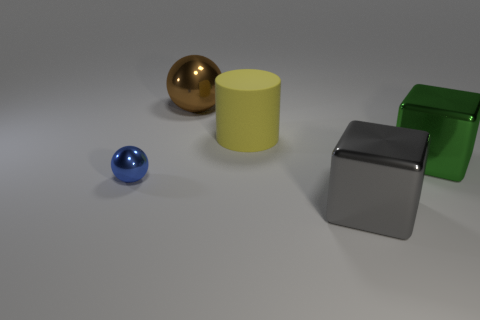How many objects are on the left side of the big gray metal object and in front of the brown metallic thing?
Provide a short and direct response. 2. Is there anything else that is the same material as the yellow thing?
Offer a terse response. No. Are there the same number of large brown things that are right of the cylinder and blue balls behind the tiny blue ball?
Give a very brief answer. Yes. Does the brown sphere have the same material as the green cube?
Make the answer very short. Yes. How many blue things are either matte cylinders or big things?
Keep it short and to the point. 0. What number of tiny blue objects are the same shape as the big brown object?
Offer a very short reply. 1. What is the big brown object made of?
Keep it short and to the point. Metal. Is the number of large green things in front of the large green block the same as the number of tiny cyan rubber blocks?
Provide a short and direct response. Yes. What shape is the yellow rubber object that is the same size as the gray metal thing?
Your answer should be compact. Cylinder. There is a big object left of the yellow cylinder; are there any tiny blue objects in front of it?
Provide a short and direct response. Yes. 